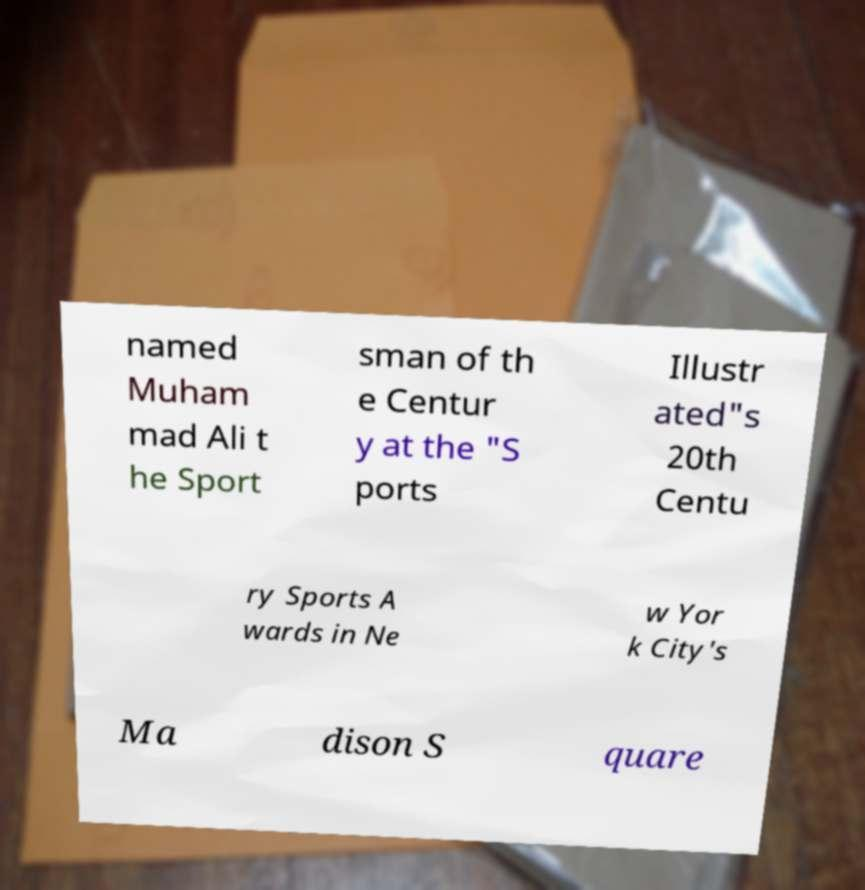For documentation purposes, I need the text within this image transcribed. Could you provide that? named Muham mad Ali t he Sport sman of th e Centur y at the "S ports Illustr ated"s 20th Centu ry Sports A wards in Ne w Yor k City's Ma dison S quare 